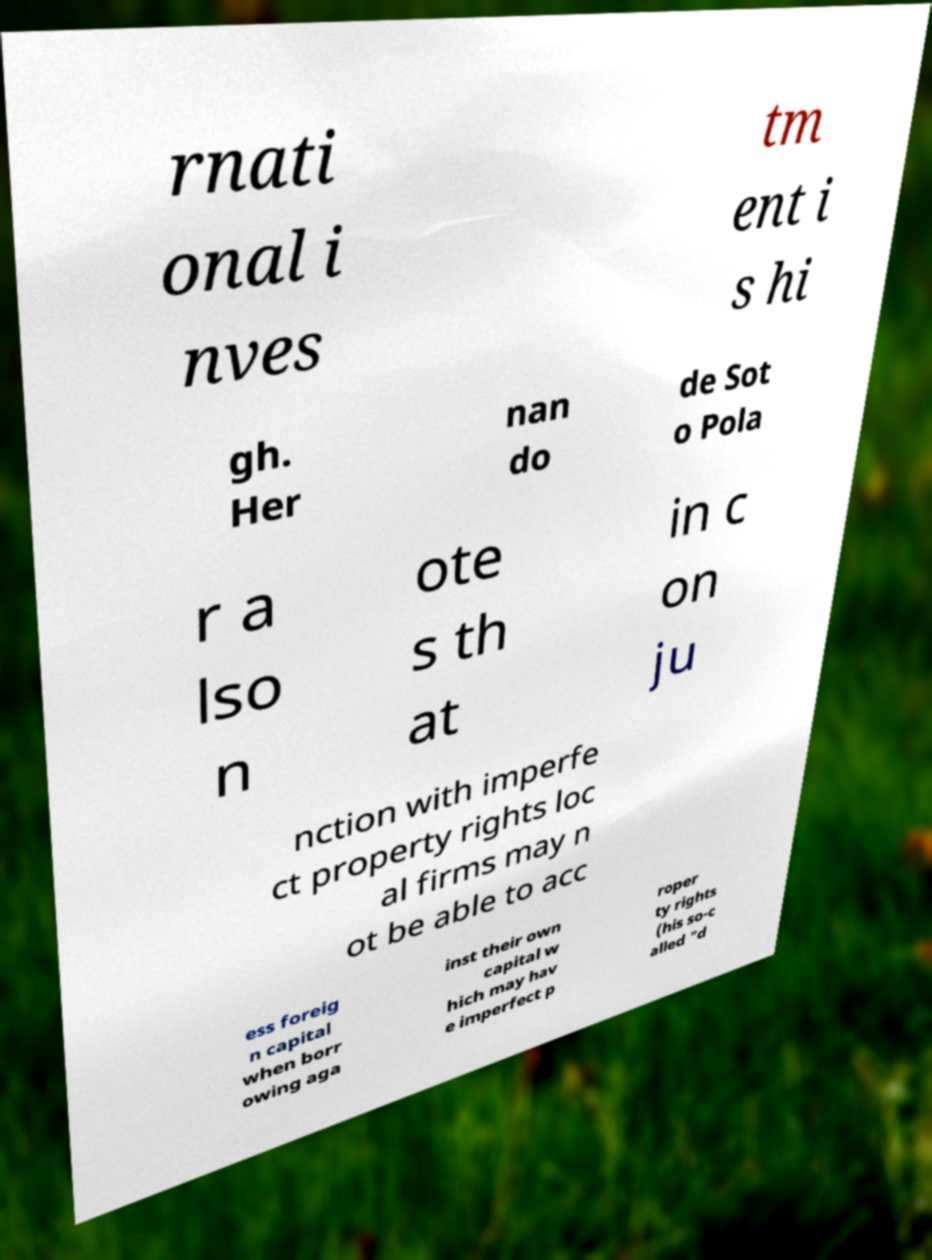Please identify and transcribe the text found in this image. rnati onal i nves tm ent i s hi gh. Her nan do de Sot o Pola r a lso n ote s th at in c on ju nction with imperfe ct property rights loc al firms may n ot be able to acc ess foreig n capital when borr owing aga inst their own capital w hich may hav e imperfect p roper ty rights (his so-c alled "d 